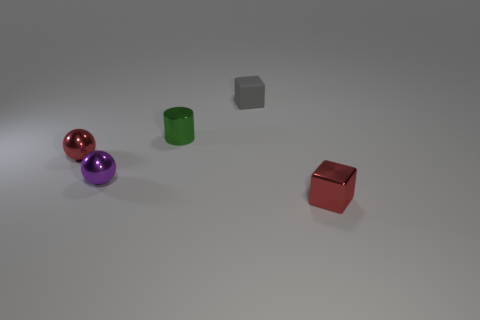What number of tiny metallic things are in front of the small green metal thing and to the left of the red metallic cube?
Provide a short and direct response. 2. There is a sphere in front of the ball behind the tiny purple thing; what size is it?
Provide a succinct answer. Small. Is the number of tiny metal objects behind the purple sphere less than the number of small purple balls that are on the right side of the small gray thing?
Your answer should be compact. No. There is a metal object that is right of the tiny green shiny cylinder; is its color the same as the cube behind the tiny green cylinder?
Offer a very short reply. No. What is the material of the thing that is in front of the small red ball and on the right side of the small purple thing?
Give a very brief answer. Metal. Are there any brown metal objects?
Offer a terse response. No. What shape is the red object that is the same material as the red ball?
Provide a succinct answer. Cube. Does the green metal thing have the same shape as the small shiny thing to the right of the small green metal cylinder?
Offer a very short reply. No. What material is the red object left of the matte thing that is behind the green cylinder?
Offer a very short reply. Metal. What number of other objects are there of the same shape as the tiny purple object?
Your answer should be very brief. 1. 